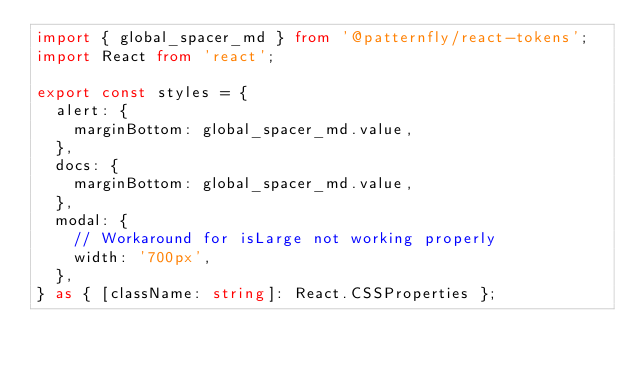<code> <loc_0><loc_0><loc_500><loc_500><_TypeScript_>import { global_spacer_md } from '@patternfly/react-tokens';
import React from 'react';

export const styles = {
  alert: {
    marginBottom: global_spacer_md.value,
  },
  docs: {
    marginBottom: global_spacer_md.value,
  },
  modal: {
    // Workaround for isLarge not working properly
    width: '700px',
  },
} as { [className: string]: React.CSSProperties };
</code> 